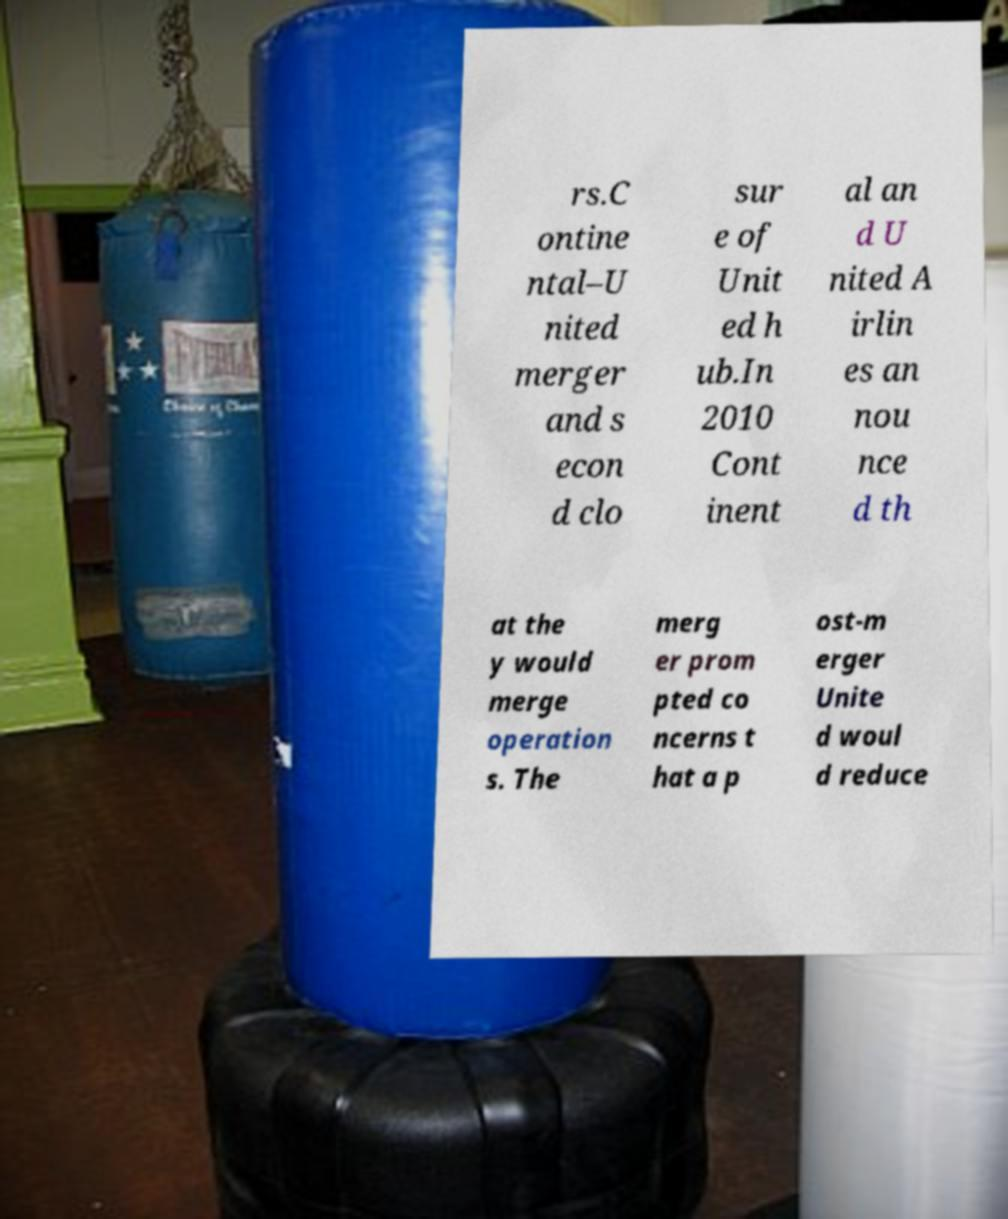Could you assist in decoding the text presented in this image and type it out clearly? rs.C ontine ntal–U nited merger and s econ d clo sur e of Unit ed h ub.In 2010 Cont inent al an d U nited A irlin es an nou nce d th at the y would merge operation s. The merg er prom pted co ncerns t hat a p ost-m erger Unite d woul d reduce 